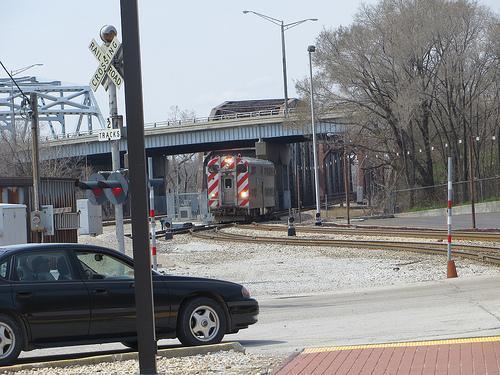How many cars are there?
Give a very brief answer. 1. 